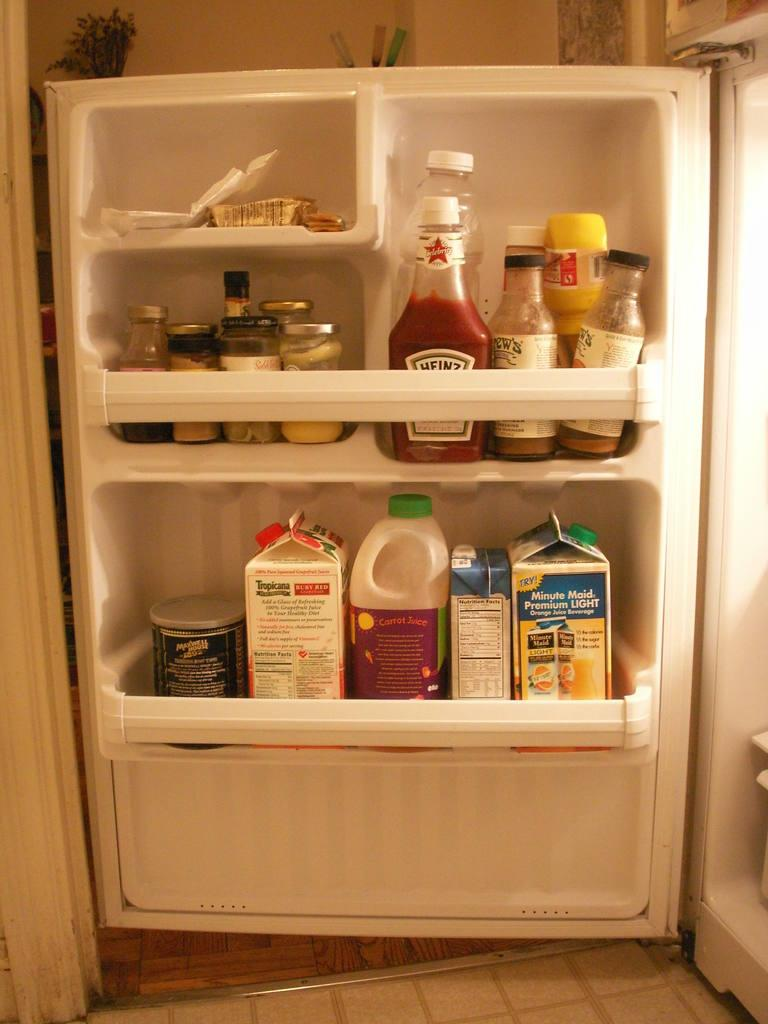Provide a one-sentence caption for the provided image. The ketchup in the fridge is made by Heinz. 